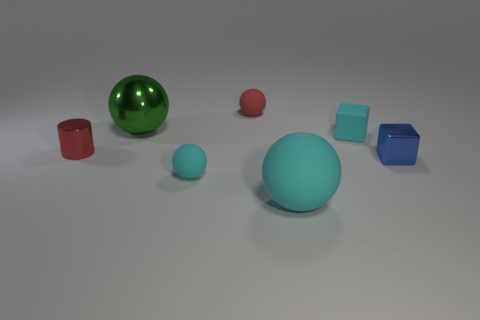Are the cyan ball that is behind the big cyan ball and the red object that is in front of the red rubber ball made of the same material?
Keep it short and to the point. No. What shape is the red rubber thing that is the same size as the blue block?
Your response must be concise. Sphere. Is there a small cyan matte thing that has the same shape as the blue thing?
Offer a terse response. Yes. Do the tiny sphere in front of the tiny metallic cylinder and the big ball that is on the right side of the tiny red ball have the same color?
Your answer should be compact. Yes. Are there any small spheres behind the small red metallic cylinder?
Your answer should be compact. Yes. The tiny object that is both in front of the red metallic thing and to the left of the red rubber object is made of what material?
Make the answer very short. Rubber. Does the small object behind the large green metal thing have the same material as the tiny cyan ball?
Your answer should be compact. Yes. What material is the red cylinder?
Offer a very short reply. Metal. There is a green sphere behind the small blue thing; how big is it?
Ensure brevity in your answer.  Large. Is there any other thing that has the same color as the tiny metallic cube?
Provide a short and direct response. No. 